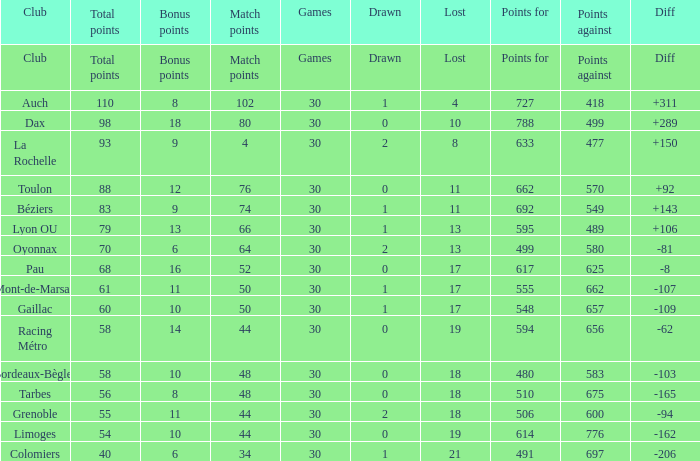For a club with 34 match points, what is the total number of games? 30.0. 